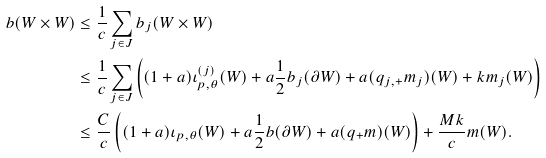Convert formula to latex. <formula><loc_0><loc_0><loc_500><loc_500>b ( W \times W ) & \leq \frac { 1 } { c } \sum _ { j \in J } b _ { j } ( W \times W ) \\ & \leq \frac { 1 } { c } \sum _ { j \in J } \left ( ( 1 + a ) \iota _ { p , \theta } ^ { ( j ) } ( W ) + a \frac { 1 } { 2 } b _ { j } ( \partial W ) + a ( q _ { j , + } m _ { j } ) ( W ) + k m _ { j } ( W ) \right ) \\ & \leq \frac { C } c \left ( ( 1 + a ) \iota _ { p , \theta } ( W ) + a \frac { 1 } { 2 } b ( \partial W ) + a ( q _ { + } m ) ( W ) \right ) + \frac { M k } { c } m ( W ) .</formula> 